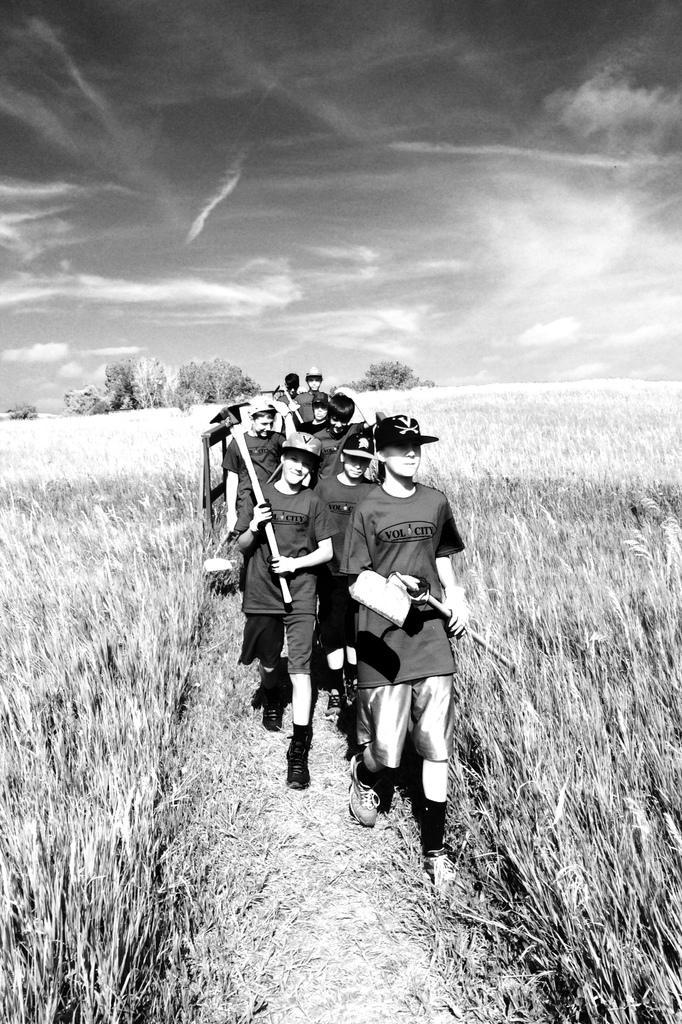Can you describe this image briefly? In this picture we can see a group of people wore caps, holding some objects with their hands and walking on the ground. In the background we can see the grass, trees and the sky. 